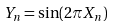Convert formula to latex. <formula><loc_0><loc_0><loc_500><loc_500>Y _ { n } = \sin ( 2 \pi X _ { n } )</formula> 